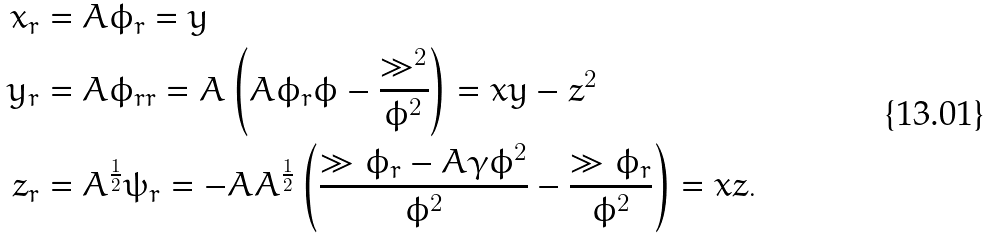<formula> <loc_0><loc_0><loc_500><loc_500>x _ { r } = & \ A \phi _ { r } = y \\ y _ { r } = & \ A \phi _ { r r } = A \left ( A \phi _ { r } \phi - \frac { \gg ^ { 2 } } { \phi ^ { 2 } } \right ) = x y - z ^ { 2 } \\ z _ { r } = & \ A ^ { \frac { 1 } { 2 } } \psi _ { r } = - A A ^ { \frac { 1 } { 2 } } \left ( \frac { \gg \phi _ { r } - A \gamma \phi ^ { 2 } } { \phi ^ { 2 } } - \frac { \gg \phi _ { r } } { \phi ^ { 2 } } \right ) = x z .</formula> 